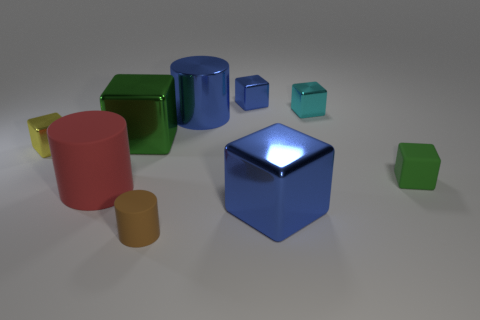Are there any tiny green objects in front of the cyan metal thing?
Make the answer very short. Yes. There is a yellow thing that is the same shape as the green matte object; what is its size?
Give a very brief answer. Small. Are there the same number of big blue metallic cubes that are left of the tiny blue shiny thing and green cubes on the right side of the green metal object?
Your answer should be compact. No. How many tiny yellow metallic cubes are there?
Keep it short and to the point. 1. Is the number of tiny brown cylinders to the left of the cyan shiny thing greater than the number of tiny blue metallic cylinders?
Your answer should be compact. Yes. What is the material of the small thing behind the small cyan shiny object?
Give a very brief answer. Metal. There is another tiny matte object that is the same shape as the tiny yellow object; what color is it?
Your response must be concise. Green. How many big blocks are the same color as the big matte cylinder?
Offer a terse response. 0. Does the green thing that is behind the small green thing have the same size as the metal thing in front of the tiny yellow shiny thing?
Offer a terse response. Yes. Is the size of the red object the same as the cube that is behind the small cyan cube?
Your answer should be very brief. No. 